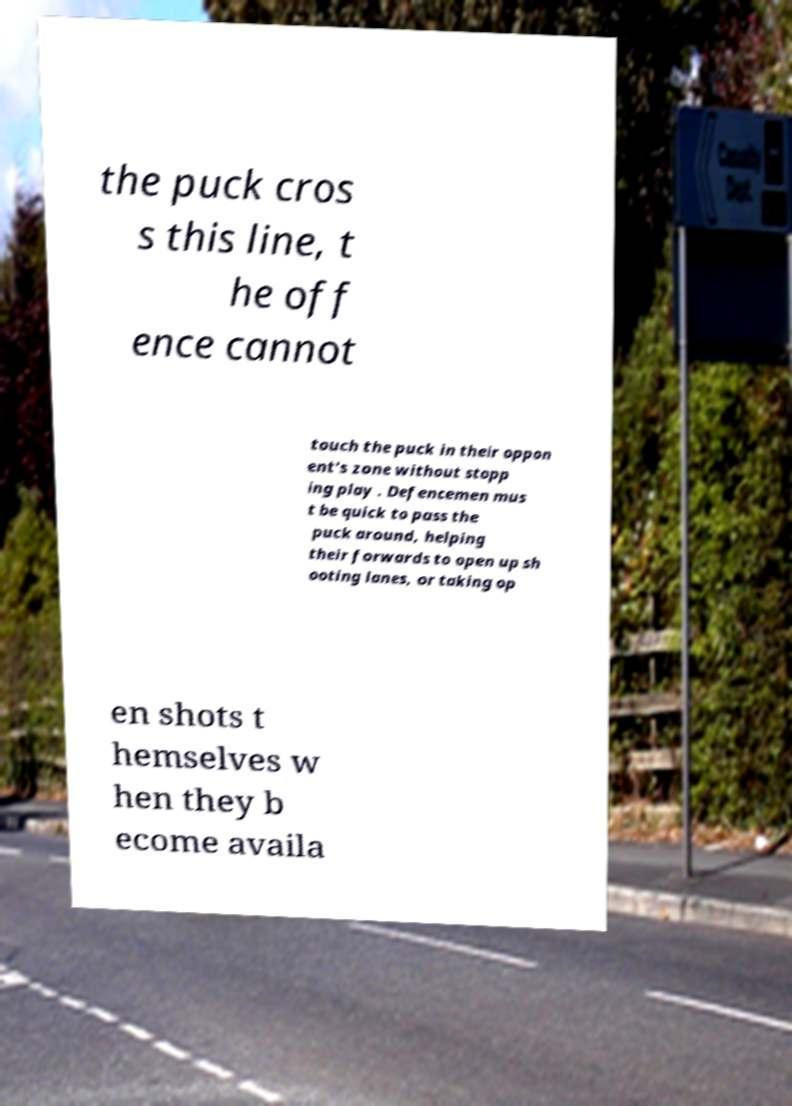Please read and relay the text visible in this image. What does it say? the puck cros s this line, t he off ence cannot touch the puck in their oppon ent's zone without stopp ing play . Defencemen mus t be quick to pass the puck around, helping their forwards to open up sh ooting lanes, or taking op en shots t hemselves w hen they b ecome availa 